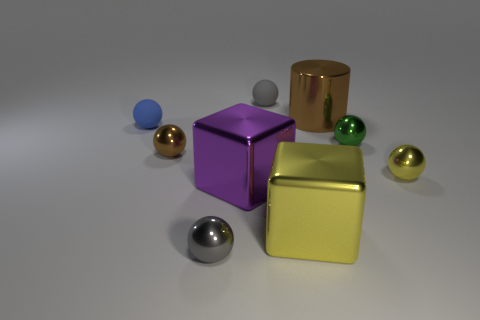What shape is the brown shiny object left of the small matte thing behind the rubber object in front of the cylinder?
Keep it short and to the point. Sphere. There is a brown ball that is the same material as the large brown thing; what size is it?
Ensure brevity in your answer.  Small. Are there more metallic blocks than tiny purple objects?
Provide a succinct answer. Yes. What is the material of the brown thing that is the same size as the purple shiny block?
Ensure brevity in your answer.  Metal. Does the rubber ball to the left of the gray shiny ball have the same size as the green metal ball?
Keep it short and to the point. Yes. What number of cylinders are large objects or small brown metallic things?
Your response must be concise. 1. There is a block on the right side of the tiny gray matte object; what is it made of?
Your answer should be very brief. Metal. Is the number of small gray metallic balls less than the number of big brown blocks?
Your response must be concise. No. What is the size of the metal sphere that is both in front of the tiny brown ball and right of the large cylinder?
Offer a terse response. Small. There is a matte ball left of the tiny matte thing behind the small matte ball in front of the big metallic cylinder; how big is it?
Your response must be concise. Small. 